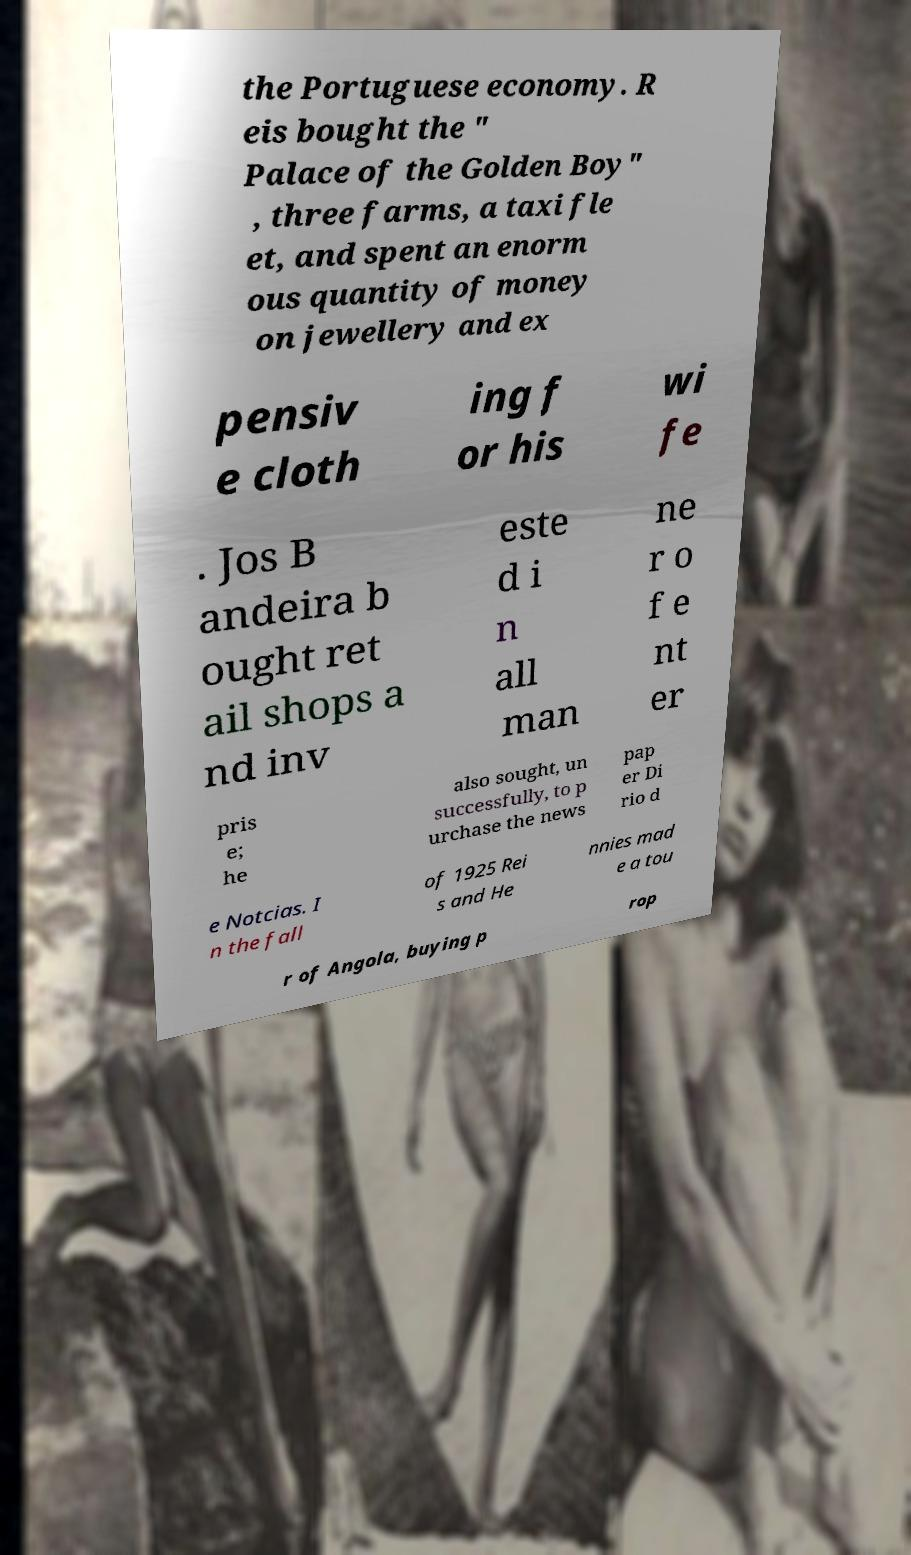What messages or text are displayed in this image? I need them in a readable, typed format. the Portuguese economy. R eis bought the " Palace of the Golden Boy" , three farms, a taxi fle et, and spent an enorm ous quantity of money on jewellery and ex pensiv e cloth ing f or his wi fe . Jos B andeira b ought ret ail shops a nd inv este d i n all man ne r o f e nt er pris e; he also sought, un successfully, to p urchase the news pap er Di rio d e Notcias. I n the fall of 1925 Rei s and He nnies mad e a tou r of Angola, buying p rop 